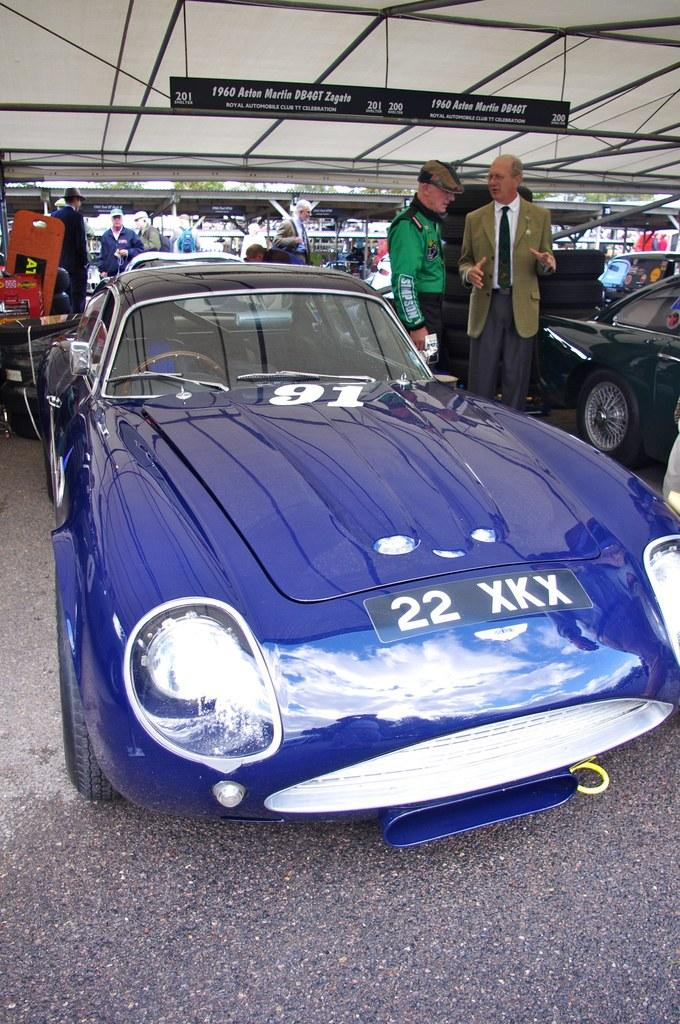What type of vehicles can be seen in the image? There are cars in the image. What are the people in the image doing? People are standing on the floor in the image. What can be seen in the background of the image? There are lights, a board with writing, and other objects in the background of the image. What type of vessel is being used by the spy in the image? There is no spy or vessel present in the image. 